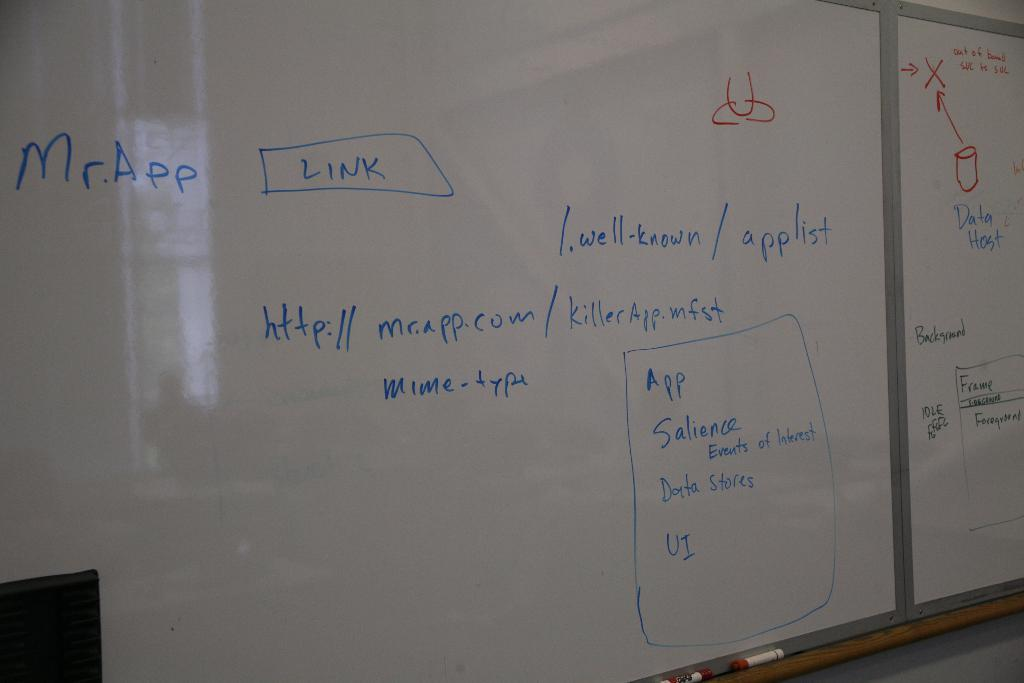<image>
Render a clear and concise summary of the photo. A white board has lots of blue writing on it including the words Mr. App. 